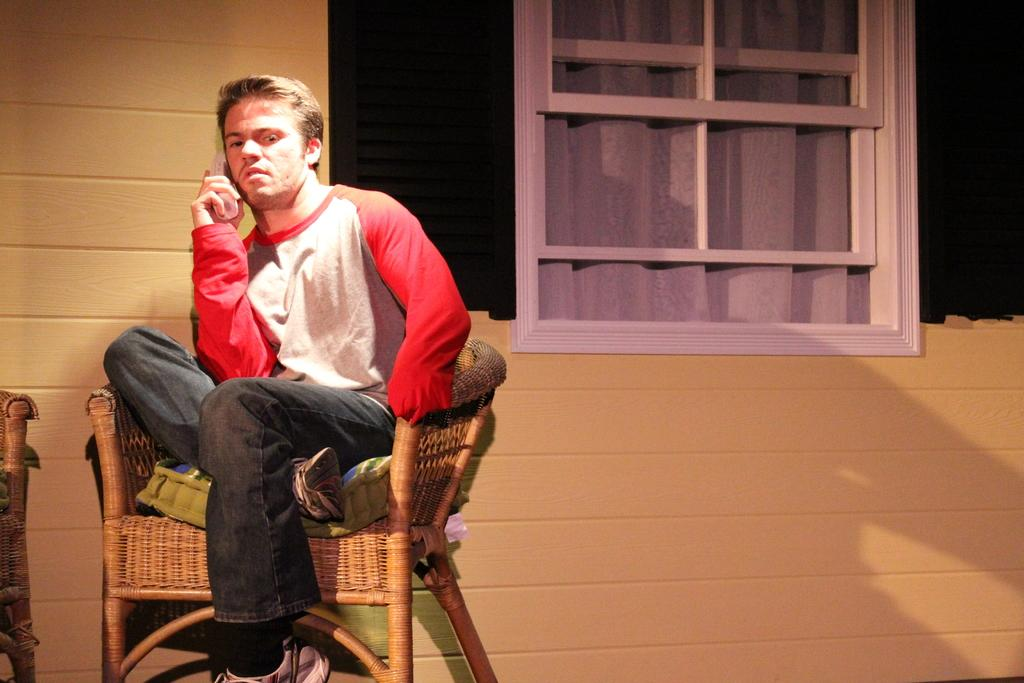What type of furniture is located on the left side of the picture? There are chairs on the left side of the picture. What is the person in the image doing? The person is holding a telephone in the image. What can be seen at the top of the image? There is a window at the top of the image. What type of window treatment is present in the image? There is a curtain associated with the window. What is the setting of the image? The background of the image appears to be a well. What type of meat is being prepared on the table in the image? There is no meat or table present in the image. What type of animal can be seen in the image? There are no animals present in the image. 